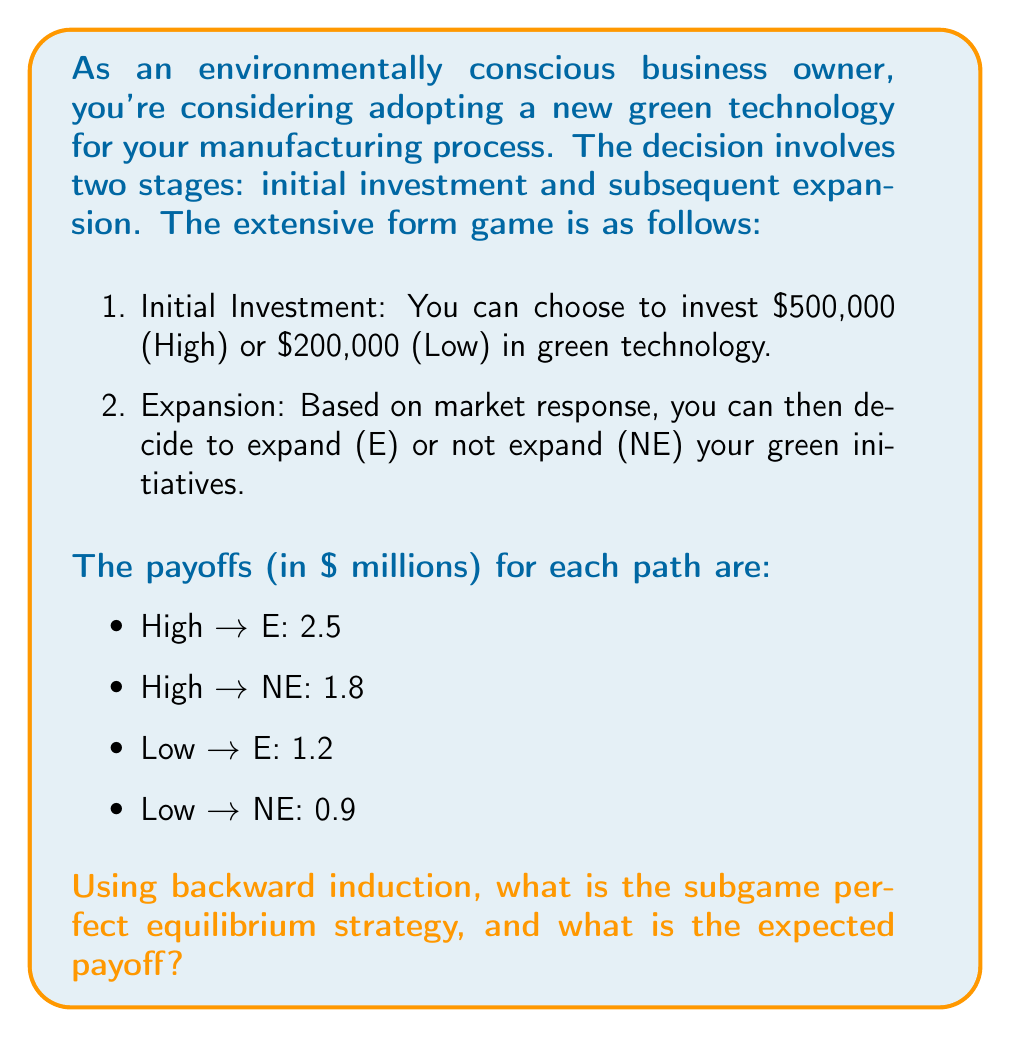Can you solve this math problem? To solve this extensive form game using backward induction, we'll start from the end and work our way back to the beginning:

1. Analyze the expansion stage:
   - If High was chosen:
     E payoff: $2.5 million
     NE payoff: $1.8 million
     Best choice: E (Expand)
   - If Low was chosen:
     E payoff: $1.2 million
     NE payoff: $0.9 million
     Best choice: E (Expand)

2. Now, knowing the best choices in the expansion stage, we can analyze the initial investment stage:
   - If High is chosen, the payoff will be $2.5 million (since E will be chosen in the expansion stage)
   - If Low is chosen, the payoff will be $1.2 million (since E will be chosen in the expansion stage)

3. Compare the payoffs at the initial investment stage:
   High: $2.5 million
   Low: $1.2 million

Therefore, the subgame perfect equilibrium strategy is:
- Choose High investment initially
- Choose to Expand in the second stage

The expected payoff is $2.5 million.

This strategy aligns with the persona of an experienced business owner who values sustainability and ethical decision-making. By making a higher initial investment in green technology and then expanding based on positive market response, the business owner demonstrates a commitment to environmental responsibility while also maximizing long-term profits.
Answer: The subgame perfect equilibrium strategy is (High, Expand) with an expected payoff of $2.5 million. 